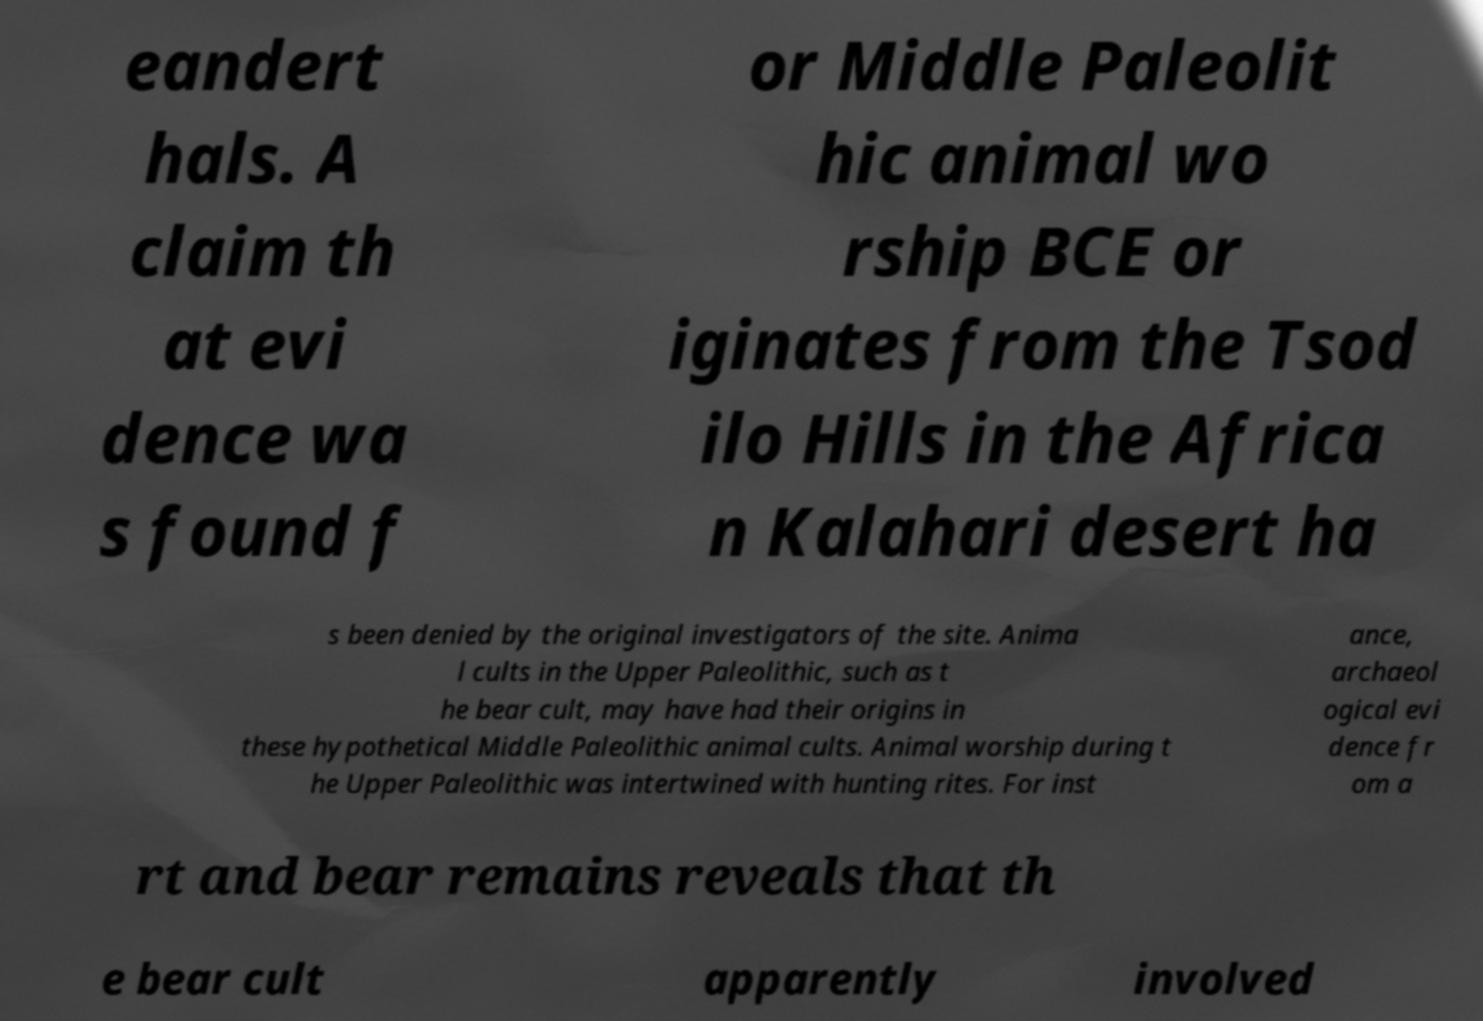Can you read and provide the text displayed in the image?This photo seems to have some interesting text. Can you extract and type it out for me? eandert hals. A claim th at evi dence wa s found f or Middle Paleolit hic animal wo rship BCE or iginates from the Tsod ilo Hills in the Africa n Kalahari desert ha s been denied by the original investigators of the site. Anima l cults in the Upper Paleolithic, such as t he bear cult, may have had their origins in these hypothetical Middle Paleolithic animal cults. Animal worship during t he Upper Paleolithic was intertwined with hunting rites. For inst ance, archaeol ogical evi dence fr om a rt and bear remains reveals that th e bear cult apparently involved 